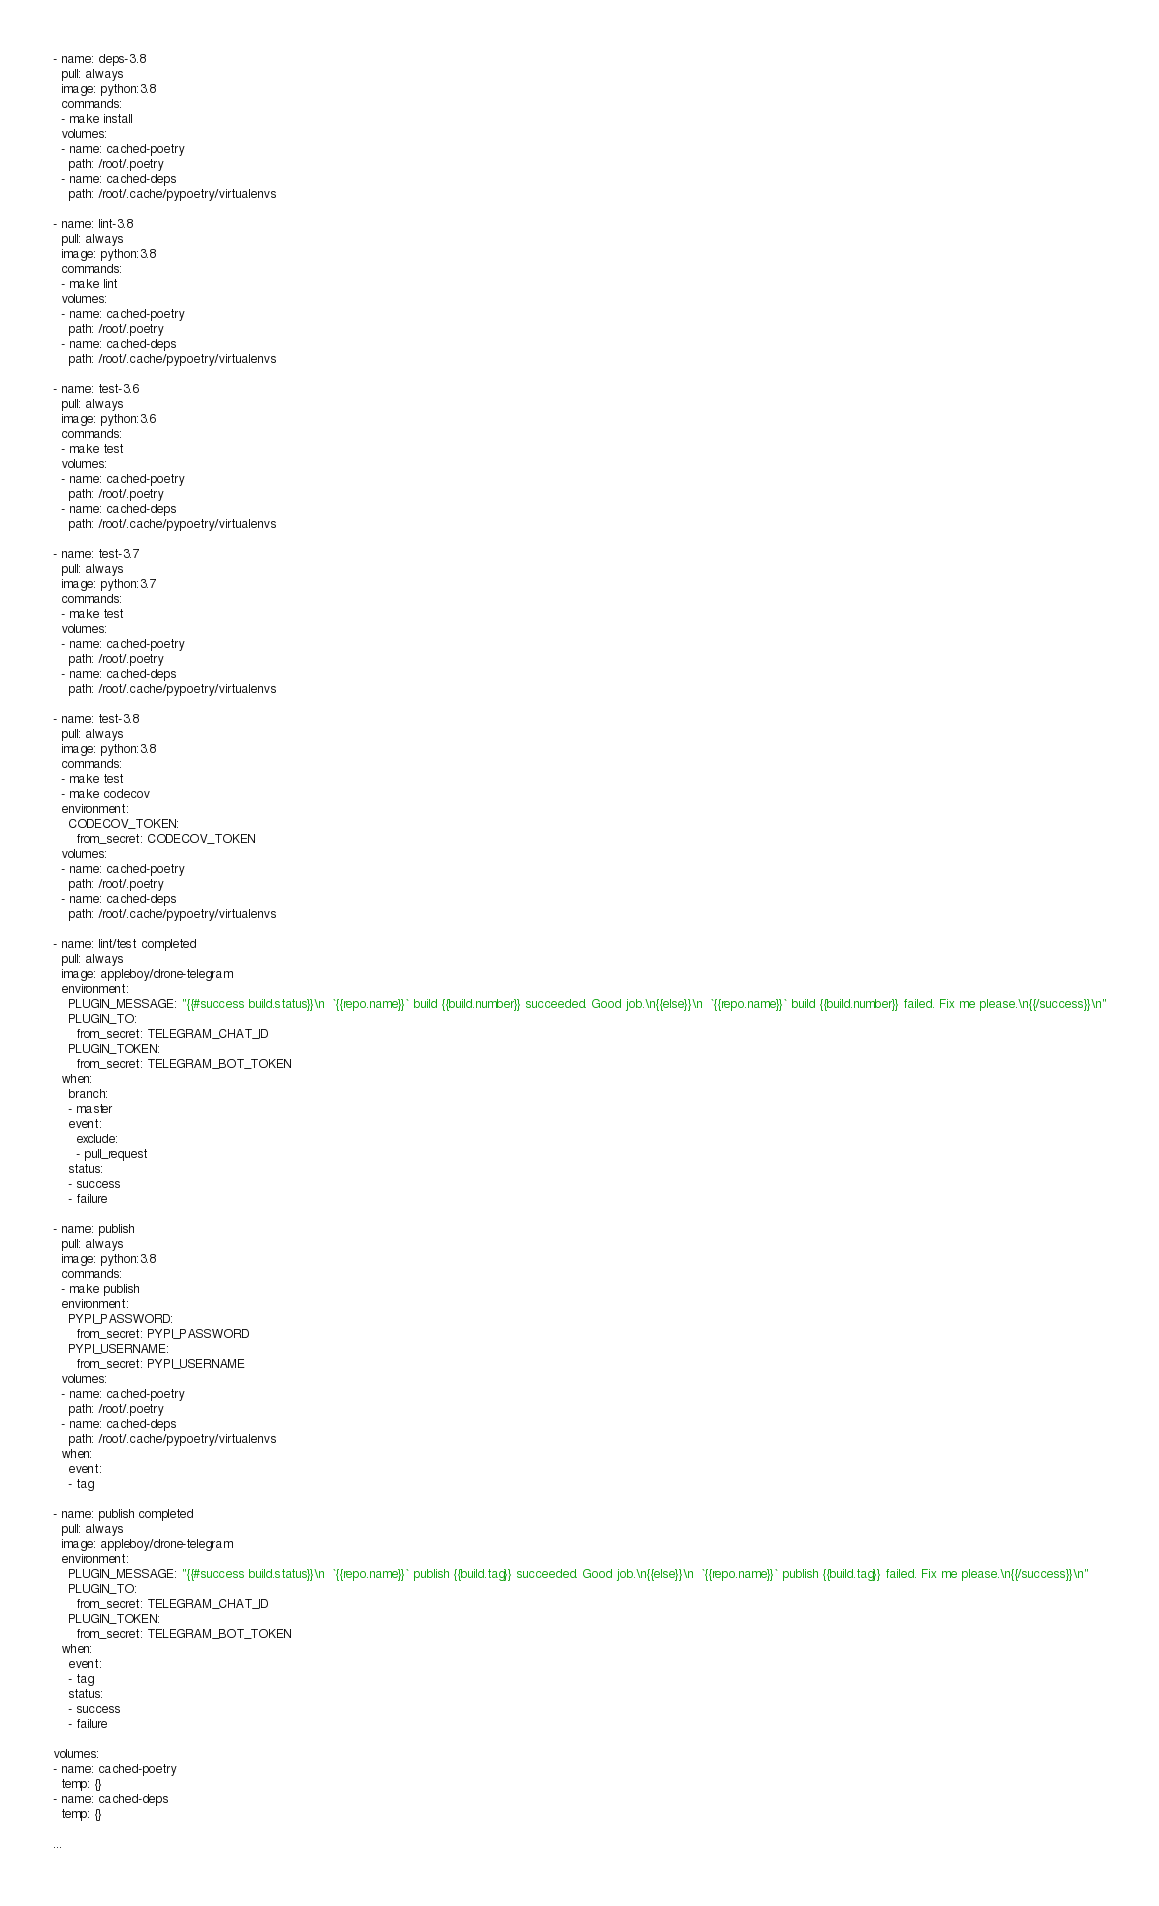<code> <loc_0><loc_0><loc_500><loc_500><_YAML_>- name: deps-3.8
  pull: always
  image: python:3.8
  commands:
  - make install
  volumes:
  - name: cached-poetry
    path: /root/.poetry
  - name: cached-deps
    path: /root/.cache/pypoetry/virtualenvs

- name: lint-3.8
  pull: always
  image: python:3.8
  commands:
  - make lint
  volumes:
  - name: cached-poetry
    path: /root/.poetry
  - name: cached-deps
    path: /root/.cache/pypoetry/virtualenvs

- name: test-3.6
  pull: always
  image: python:3.6
  commands:
  - make test
  volumes:
  - name: cached-poetry
    path: /root/.poetry
  - name: cached-deps
    path: /root/.cache/pypoetry/virtualenvs

- name: test-3.7
  pull: always
  image: python:3.7
  commands:
  - make test
  volumes:
  - name: cached-poetry
    path: /root/.poetry
  - name: cached-deps
    path: /root/.cache/pypoetry/virtualenvs

- name: test-3.8
  pull: always
  image: python:3.8
  commands:
  - make test
  - make codecov
  environment:
    CODECOV_TOKEN:
      from_secret: CODECOV_TOKEN
  volumes:
  - name: cached-poetry
    path: /root/.poetry
  - name: cached-deps
    path: /root/.cache/pypoetry/virtualenvs

- name: lint/test completed
  pull: always
  image: appleboy/drone-telegram
  environment:
    PLUGIN_MESSAGE: "{{#success build.status}}\n  `{{repo.name}}` build {{build.number}} succeeded. Good job.\n{{else}}\n  `{{repo.name}}` build {{build.number}} failed. Fix me please.\n{{/success}}\n"
    PLUGIN_TO:
      from_secret: TELEGRAM_CHAT_ID
    PLUGIN_TOKEN:
      from_secret: TELEGRAM_BOT_TOKEN
  when:
    branch:
    - master
    event:
      exclude:
      - pull_request
    status:
    - success
    - failure

- name: publish
  pull: always
  image: python:3.8
  commands:
  - make publish
  environment:
    PYPI_PASSWORD:
      from_secret: PYPI_PASSWORD
    PYPI_USERNAME:
      from_secret: PYPI_USERNAME
  volumes:
  - name: cached-poetry
    path: /root/.poetry
  - name: cached-deps
    path: /root/.cache/pypoetry/virtualenvs
  when:
    event:
    - tag

- name: publish completed
  pull: always
  image: appleboy/drone-telegram
  environment:
    PLUGIN_MESSAGE: "{{#success build.status}}\n  `{{repo.name}}` publish {{build.tag}} succeeded. Good job.\n{{else}}\n  `{{repo.name}}` publish {{build.tag}} failed. Fix me please.\n{{/success}}\n"
    PLUGIN_TO:
      from_secret: TELEGRAM_CHAT_ID
    PLUGIN_TOKEN:
      from_secret: TELEGRAM_BOT_TOKEN
  when:
    event:
    - tag
    status:
    - success
    - failure

volumes:
- name: cached-poetry
  temp: {}
- name: cached-deps
  temp: {}

...
</code> 